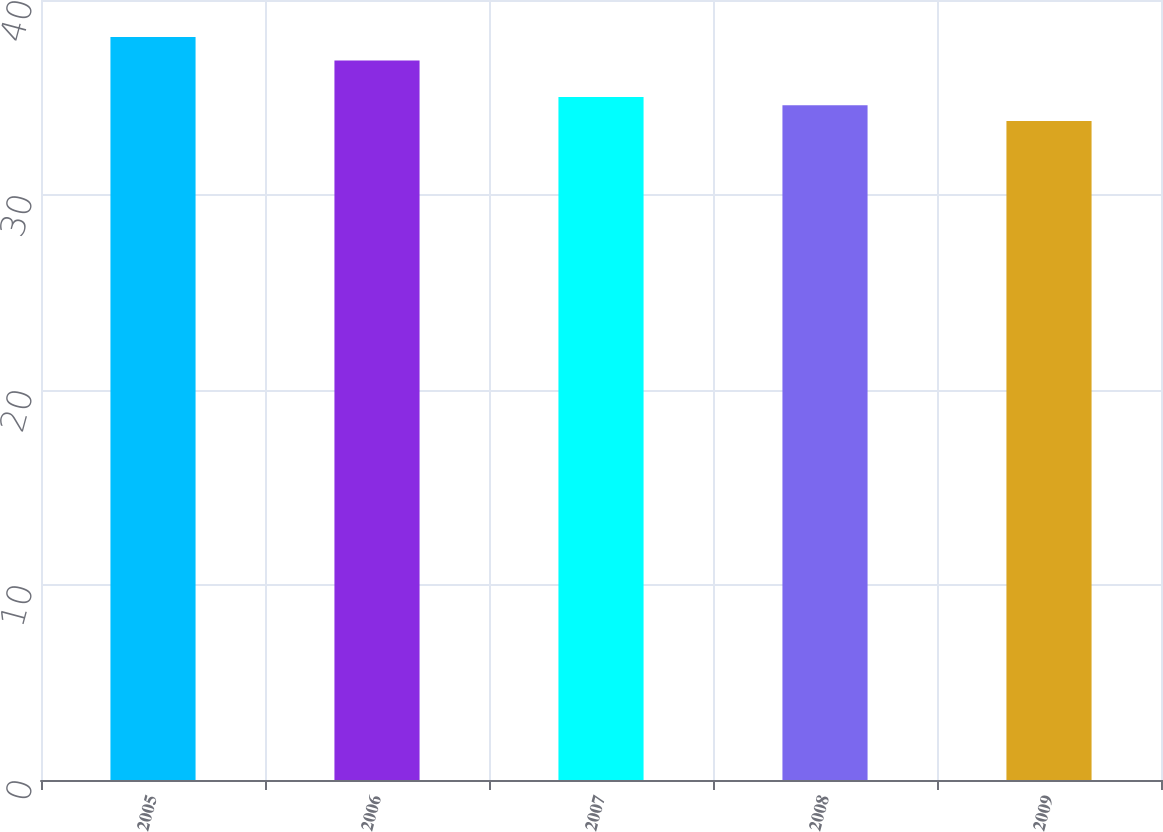<chart> <loc_0><loc_0><loc_500><loc_500><bar_chart><fcel>2005<fcel>2006<fcel>2007<fcel>2008<fcel>2009<nl><fcel>38.1<fcel>36.9<fcel>35.03<fcel>34.6<fcel>33.8<nl></chart> 